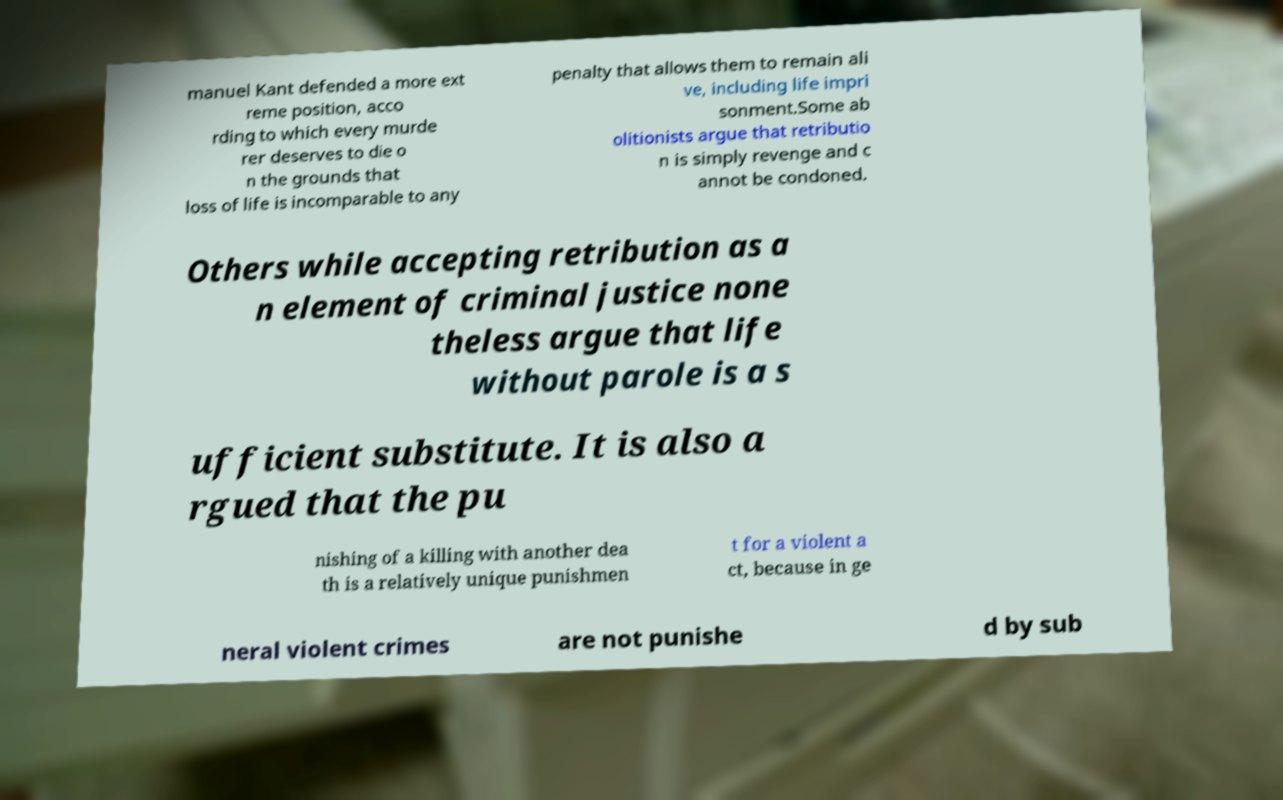I need the written content from this picture converted into text. Can you do that? manuel Kant defended a more ext reme position, acco rding to which every murde rer deserves to die o n the grounds that loss of life is incomparable to any penalty that allows them to remain ali ve, including life impri sonment.Some ab olitionists argue that retributio n is simply revenge and c annot be condoned. Others while accepting retribution as a n element of criminal justice none theless argue that life without parole is a s ufficient substitute. It is also a rgued that the pu nishing of a killing with another dea th is a relatively unique punishmen t for a violent a ct, because in ge neral violent crimes are not punishe d by sub 